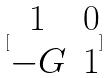Convert formula to latex. <formula><loc_0><loc_0><loc_500><loc_500>[ \begin{matrix} 1 & 0 \\ - G & 1 \end{matrix} ]</formula> 